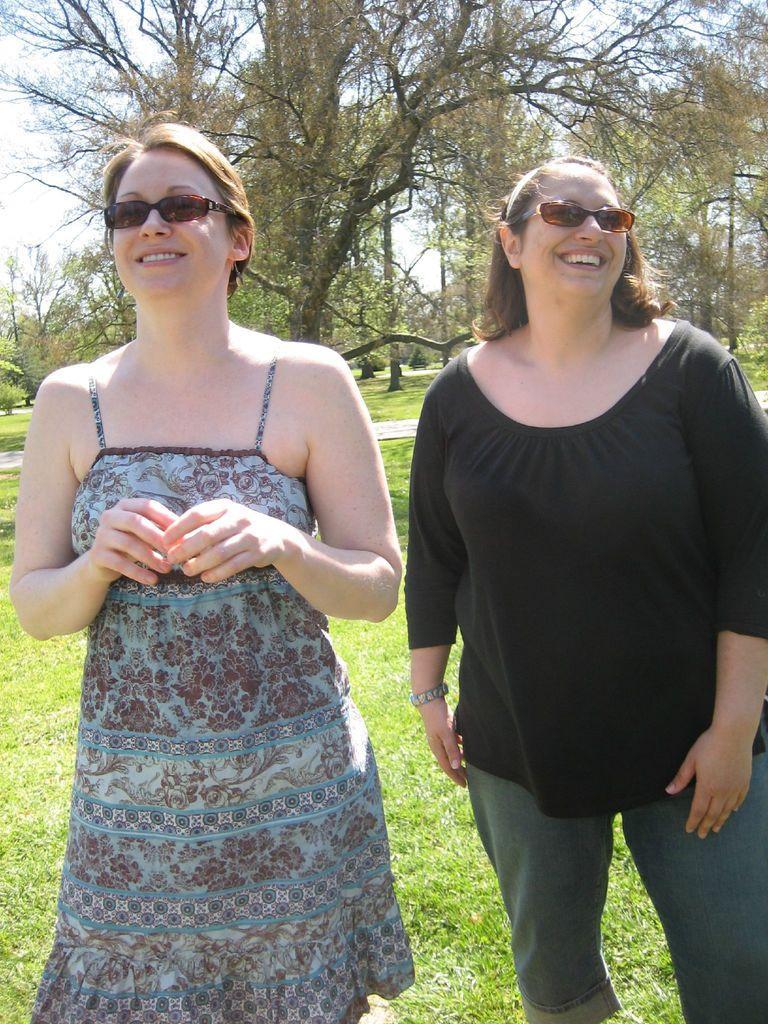Describe this image in one or two sentences. In this image we can see woman standing on the ground. In the background we can see trees and sky. 